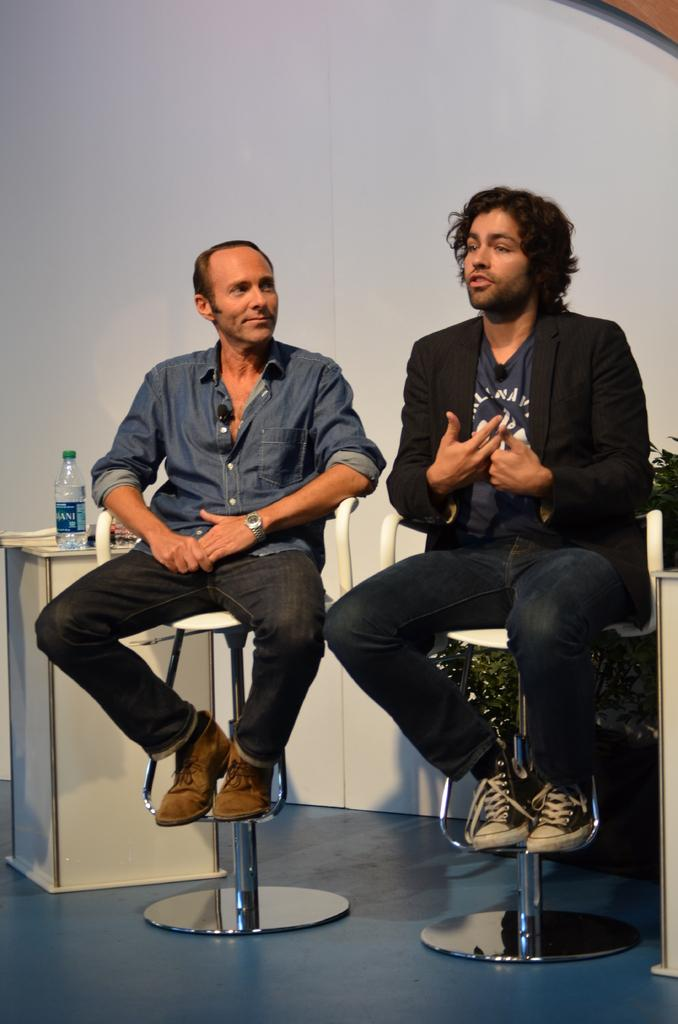How many people are in the image? There are two men in the image. What are the men doing in the image? The men are sitting on chairs. What type of picture is hanging on the wall behind the men? There is no mention of a picture hanging on the wall behind the men in the provided facts. 